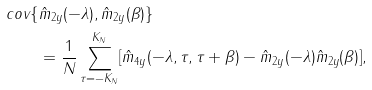<formula> <loc_0><loc_0><loc_500><loc_500>c o v \{ & \hat { m } _ { 2 y } ( - \lambda ) , \hat { m } _ { 2 y } ( \beta ) \} \\ & = \frac { 1 } { N } \sum _ { \tau = - K _ { N } } ^ { K _ { N } } [ \hat { m } _ { 4 y } ( - \lambda , \tau , \tau + \beta ) - \hat { m } _ { 2 y } ( - \lambda ) \hat { m } _ { 2 y } ( \beta ) ] ,</formula> 